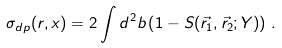<formula> <loc_0><loc_0><loc_500><loc_500>\sigma _ { d p } ( r , x ) = 2 \int d ^ { 2 } b \left ( 1 - S ( \vec { r } _ { 1 } , \vec { r } _ { 2 } ; Y ) \right ) \, .</formula> 